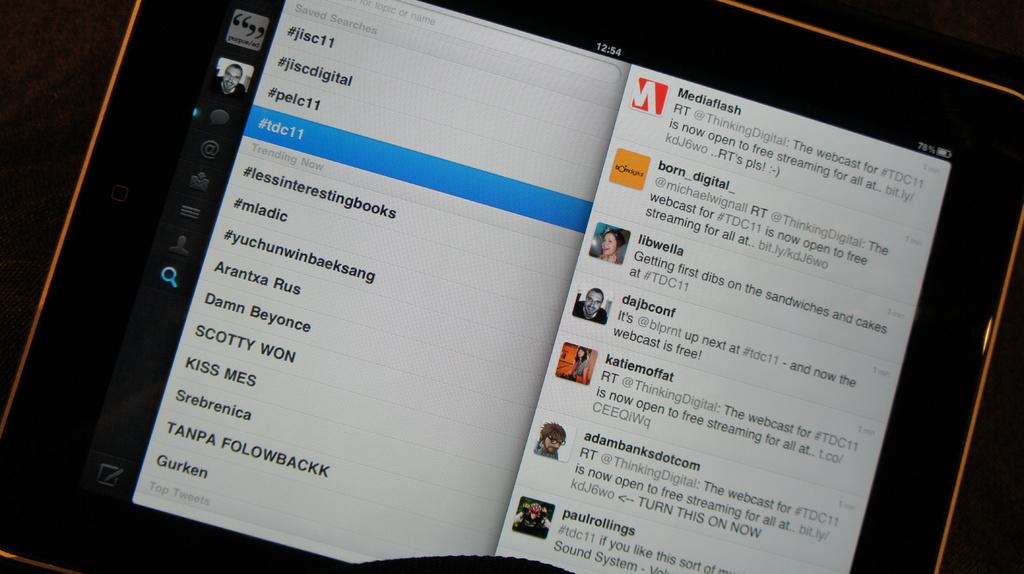What type of electronic device is visible in the image? There is an electronic gadget in the image. What feature does the electronic gadget have? The electronic gadget has a screen. What can be seen on the screen of the electronic gadget? There are pictures displayed on the screen, and there is also text written on the screen. How many eggs are being used in the volleyball game in the image? There is no volleyball game or eggs present in the image. 